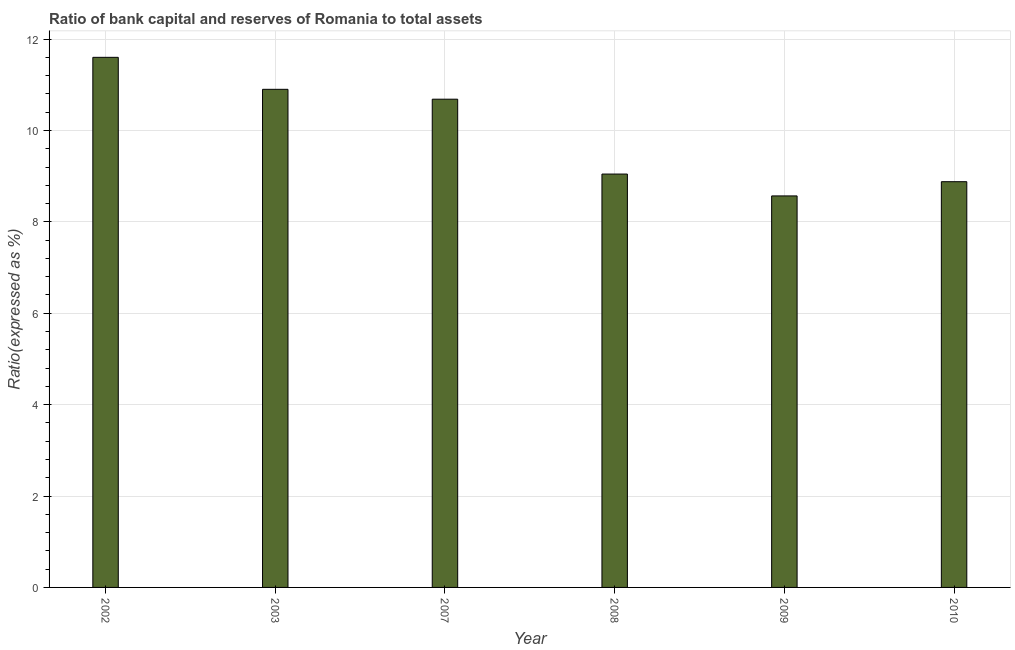Does the graph contain any zero values?
Your answer should be compact. No. What is the title of the graph?
Your response must be concise. Ratio of bank capital and reserves of Romania to total assets. What is the label or title of the Y-axis?
Provide a succinct answer. Ratio(expressed as %). What is the bank capital to assets ratio in 2008?
Provide a succinct answer. 9.05. Across all years, what is the minimum bank capital to assets ratio?
Ensure brevity in your answer.  8.57. In which year was the bank capital to assets ratio minimum?
Make the answer very short. 2009. What is the sum of the bank capital to assets ratio?
Ensure brevity in your answer.  59.68. What is the difference between the bank capital to assets ratio in 2007 and 2010?
Provide a succinct answer. 1.8. What is the average bank capital to assets ratio per year?
Provide a short and direct response. 9.95. What is the median bank capital to assets ratio?
Make the answer very short. 9.86. In how many years, is the bank capital to assets ratio greater than 1.6 %?
Your answer should be compact. 6. Do a majority of the years between 2007 and 2010 (inclusive) have bank capital to assets ratio greater than 10.4 %?
Your response must be concise. No. What is the ratio of the bank capital to assets ratio in 2003 to that in 2009?
Give a very brief answer. 1.27. Is the difference between the bank capital to assets ratio in 2009 and 2010 greater than the difference between any two years?
Keep it short and to the point. No. What is the difference between the highest and the lowest bank capital to assets ratio?
Keep it short and to the point. 3.03. In how many years, is the bank capital to assets ratio greater than the average bank capital to assets ratio taken over all years?
Offer a terse response. 3. How many bars are there?
Give a very brief answer. 6. Are all the bars in the graph horizontal?
Keep it short and to the point. No. How many years are there in the graph?
Give a very brief answer. 6. What is the Ratio(expressed as %) in 2002?
Provide a short and direct response. 11.6. What is the Ratio(expressed as %) in 2007?
Keep it short and to the point. 10.68. What is the Ratio(expressed as %) of 2008?
Provide a succinct answer. 9.05. What is the Ratio(expressed as %) in 2009?
Your answer should be compact. 8.57. What is the Ratio(expressed as %) of 2010?
Your response must be concise. 8.88. What is the difference between the Ratio(expressed as %) in 2002 and 2007?
Keep it short and to the point. 0.92. What is the difference between the Ratio(expressed as %) in 2002 and 2008?
Give a very brief answer. 2.55. What is the difference between the Ratio(expressed as %) in 2002 and 2009?
Your answer should be compact. 3.03. What is the difference between the Ratio(expressed as %) in 2002 and 2010?
Your answer should be very brief. 2.72. What is the difference between the Ratio(expressed as %) in 2003 and 2007?
Provide a short and direct response. 0.22. What is the difference between the Ratio(expressed as %) in 2003 and 2008?
Make the answer very short. 1.85. What is the difference between the Ratio(expressed as %) in 2003 and 2009?
Keep it short and to the point. 2.33. What is the difference between the Ratio(expressed as %) in 2003 and 2010?
Make the answer very short. 2.02. What is the difference between the Ratio(expressed as %) in 2007 and 2008?
Keep it short and to the point. 1.64. What is the difference between the Ratio(expressed as %) in 2007 and 2009?
Provide a succinct answer. 2.12. What is the difference between the Ratio(expressed as %) in 2007 and 2010?
Provide a succinct answer. 1.81. What is the difference between the Ratio(expressed as %) in 2008 and 2009?
Make the answer very short. 0.48. What is the difference between the Ratio(expressed as %) in 2008 and 2010?
Your answer should be compact. 0.17. What is the difference between the Ratio(expressed as %) in 2009 and 2010?
Provide a short and direct response. -0.31. What is the ratio of the Ratio(expressed as %) in 2002 to that in 2003?
Your answer should be very brief. 1.06. What is the ratio of the Ratio(expressed as %) in 2002 to that in 2007?
Give a very brief answer. 1.09. What is the ratio of the Ratio(expressed as %) in 2002 to that in 2008?
Your answer should be compact. 1.28. What is the ratio of the Ratio(expressed as %) in 2002 to that in 2009?
Your answer should be very brief. 1.35. What is the ratio of the Ratio(expressed as %) in 2002 to that in 2010?
Provide a short and direct response. 1.31. What is the ratio of the Ratio(expressed as %) in 2003 to that in 2008?
Make the answer very short. 1.21. What is the ratio of the Ratio(expressed as %) in 2003 to that in 2009?
Give a very brief answer. 1.27. What is the ratio of the Ratio(expressed as %) in 2003 to that in 2010?
Provide a succinct answer. 1.23. What is the ratio of the Ratio(expressed as %) in 2007 to that in 2008?
Ensure brevity in your answer.  1.18. What is the ratio of the Ratio(expressed as %) in 2007 to that in 2009?
Keep it short and to the point. 1.25. What is the ratio of the Ratio(expressed as %) in 2007 to that in 2010?
Ensure brevity in your answer.  1.2. What is the ratio of the Ratio(expressed as %) in 2008 to that in 2009?
Offer a terse response. 1.06. 